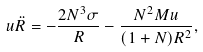<formula> <loc_0><loc_0><loc_500><loc_500>u \ddot { R } = - \frac { 2 N ^ { 3 } \sigma } R - \frac { N ^ { 2 } M u } { ( 1 + N ) R ^ { 2 } } ,</formula> 